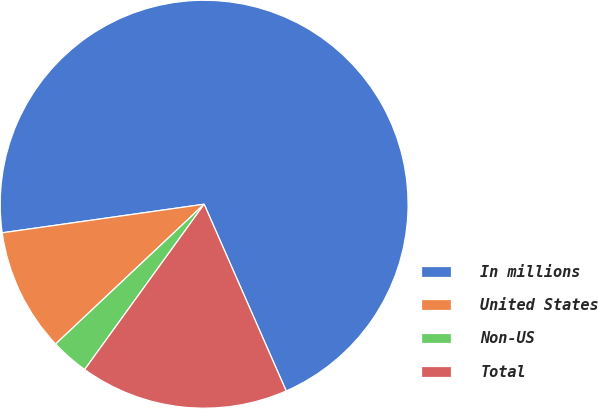Convert chart. <chart><loc_0><loc_0><loc_500><loc_500><pie_chart><fcel>In millions<fcel>United States<fcel>Non-US<fcel>Total<nl><fcel>70.65%<fcel>9.78%<fcel>3.02%<fcel>16.55%<nl></chart> 